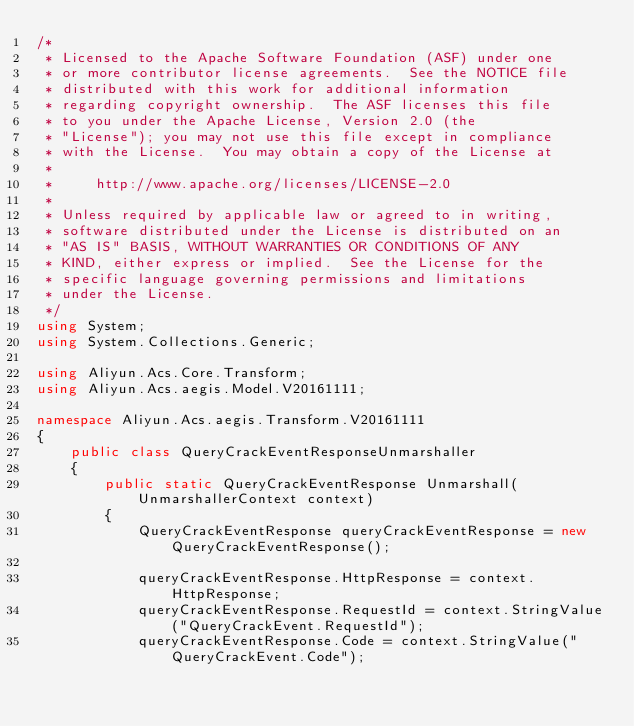<code> <loc_0><loc_0><loc_500><loc_500><_C#_>/*
 * Licensed to the Apache Software Foundation (ASF) under one
 * or more contributor license agreements.  See the NOTICE file
 * distributed with this work for additional information
 * regarding copyright ownership.  The ASF licenses this file
 * to you under the Apache License, Version 2.0 (the
 * "License"); you may not use this file except in compliance
 * with the License.  You may obtain a copy of the License at
 *
 *     http://www.apache.org/licenses/LICENSE-2.0
 *
 * Unless required by applicable law or agreed to in writing,
 * software distributed under the License is distributed on an
 * "AS IS" BASIS, WITHOUT WARRANTIES OR CONDITIONS OF ANY
 * KIND, either express or implied.  See the License for the
 * specific language governing permissions and limitations
 * under the License.
 */
using System;
using System.Collections.Generic;

using Aliyun.Acs.Core.Transform;
using Aliyun.Acs.aegis.Model.V20161111;

namespace Aliyun.Acs.aegis.Transform.V20161111
{
    public class QueryCrackEventResponseUnmarshaller
    {
        public static QueryCrackEventResponse Unmarshall(UnmarshallerContext context)
        {
			QueryCrackEventResponse queryCrackEventResponse = new QueryCrackEventResponse();

			queryCrackEventResponse.HttpResponse = context.HttpResponse;
			queryCrackEventResponse.RequestId = context.StringValue("QueryCrackEvent.RequestId");
			queryCrackEventResponse.Code = context.StringValue("QueryCrackEvent.Code");</code> 